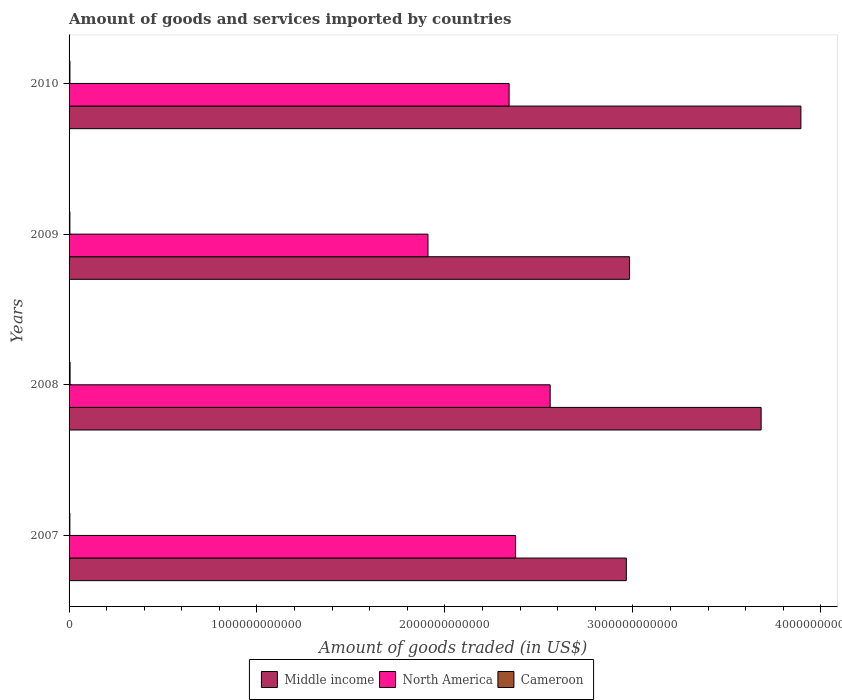Are the number of bars per tick equal to the number of legend labels?
Your answer should be very brief. Yes. How many bars are there on the 2nd tick from the top?
Provide a short and direct response. 3. What is the label of the 2nd group of bars from the top?
Your answer should be very brief. 2009. In how many cases, is the number of bars for a given year not equal to the number of legend labels?
Keep it short and to the point. 0. What is the total amount of goods and services imported in North America in 2010?
Offer a very short reply. 2.34e+12. Across all years, what is the maximum total amount of goods and services imported in Cameroon?
Offer a very short reply. 5.36e+09. Across all years, what is the minimum total amount of goods and services imported in North America?
Your response must be concise. 1.91e+12. In which year was the total amount of goods and services imported in Cameroon maximum?
Offer a very short reply. 2008. What is the total total amount of goods and services imported in North America in the graph?
Your answer should be very brief. 9.19e+12. What is the difference between the total amount of goods and services imported in Middle income in 2008 and that in 2010?
Give a very brief answer. -2.12e+11. What is the difference between the total amount of goods and services imported in Middle income in 2008 and the total amount of goods and services imported in North America in 2007?
Your answer should be compact. 1.31e+12. What is the average total amount of goods and services imported in Cameroon per year?
Keep it short and to the point. 4.62e+09. In the year 2008, what is the difference between the total amount of goods and services imported in Middle income and total amount of goods and services imported in North America?
Ensure brevity in your answer.  1.12e+12. In how many years, is the total amount of goods and services imported in North America greater than 1800000000000 US$?
Your answer should be very brief. 4. What is the ratio of the total amount of goods and services imported in Middle income in 2007 to that in 2009?
Give a very brief answer. 0.99. Is the total amount of goods and services imported in Middle income in 2008 less than that in 2009?
Your response must be concise. No. What is the difference between the highest and the second highest total amount of goods and services imported in Cameroon?
Keep it short and to the point. 7.32e+08. What is the difference between the highest and the lowest total amount of goods and services imported in Middle income?
Your answer should be compact. 9.29e+11. What does the 1st bar from the bottom in 2008 represents?
Offer a terse response. Middle income. Is it the case that in every year, the sum of the total amount of goods and services imported in Middle income and total amount of goods and services imported in North America is greater than the total amount of goods and services imported in Cameroon?
Your answer should be compact. Yes. What is the difference between two consecutive major ticks on the X-axis?
Your answer should be very brief. 1.00e+12. Are the values on the major ticks of X-axis written in scientific E-notation?
Your response must be concise. No. Does the graph contain any zero values?
Make the answer very short. No. Does the graph contain grids?
Offer a terse response. No. How many legend labels are there?
Your response must be concise. 3. What is the title of the graph?
Provide a short and direct response. Amount of goods and services imported by countries. What is the label or title of the X-axis?
Make the answer very short. Amount of goods traded (in US$). What is the label or title of the Y-axis?
Your answer should be very brief. Years. What is the Amount of goods traded (in US$) in Middle income in 2007?
Ensure brevity in your answer.  2.97e+12. What is the Amount of goods traded (in US$) in North America in 2007?
Provide a short and direct response. 2.38e+12. What is the Amount of goods traded (in US$) of Cameroon in 2007?
Offer a very short reply. 4.22e+09. What is the Amount of goods traded (in US$) in Middle income in 2008?
Keep it short and to the point. 3.68e+12. What is the Amount of goods traded (in US$) of North America in 2008?
Your answer should be very brief. 2.56e+12. What is the Amount of goods traded (in US$) of Cameroon in 2008?
Provide a succinct answer. 5.36e+09. What is the Amount of goods traded (in US$) in Middle income in 2009?
Make the answer very short. 2.98e+12. What is the Amount of goods traded (in US$) of North America in 2009?
Keep it short and to the point. 1.91e+12. What is the Amount of goods traded (in US$) of Cameroon in 2009?
Ensure brevity in your answer.  4.27e+09. What is the Amount of goods traded (in US$) in Middle income in 2010?
Offer a terse response. 3.89e+12. What is the Amount of goods traded (in US$) of North America in 2010?
Offer a very short reply. 2.34e+12. What is the Amount of goods traded (in US$) of Cameroon in 2010?
Your answer should be compact. 4.63e+09. Across all years, what is the maximum Amount of goods traded (in US$) of Middle income?
Provide a succinct answer. 3.89e+12. Across all years, what is the maximum Amount of goods traded (in US$) of North America?
Provide a succinct answer. 2.56e+12. Across all years, what is the maximum Amount of goods traded (in US$) in Cameroon?
Your response must be concise. 5.36e+09. Across all years, what is the minimum Amount of goods traded (in US$) of Middle income?
Your answer should be very brief. 2.97e+12. Across all years, what is the minimum Amount of goods traded (in US$) in North America?
Ensure brevity in your answer.  1.91e+12. Across all years, what is the minimum Amount of goods traded (in US$) in Cameroon?
Ensure brevity in your answer.  4.22e+09. What is the total Amount of goods traded (in US$) of Middle income in the graph?
Provide a short and direct response. 1.35e+13. What is the total Amount of goods traded (in US$) in North America in the graph?
Your response must be concise. 9.19e+12. What is the total Amount of goods traded (in US$) of Cameroon in the graph?
Provide a short and direct response. 1.85e+1. What is the difference between the Amount of goods traded (in US$) in Middle income in 2007 and that in 2008?
Your answer should be compact. -7.17e+11. What is the difference between the Amount of goods traded (in US$) in North America in 2007 and that in 2008?
Your response must be concise. -1.84e+11. What is the difference between the Amount of goods traded (in US$) of Cameroon in 2007 and that in 2008?
Your answer should be very brief. -1.14e+09. What is the difference between the Amount of goods traded (in US$) of Middle income in 2007 and that in 2009?
Your response must be concise. -1.71e+1. What is the difference between the Amount of goods traded (in US$) in North America in 2007 and that in 2009?
Ensure brevity in your answer.  4.66e+11. What is the difference between the Amount of goods traded (in US$) in Cameroon in 2007 and that in 2009?
Provide a succinct answer. -5.08e+07. What is the difference between the Amount of goods traded (in US$) of Middle income in 2007 and that in 2010?
Your response must be concise. -9.29e+11. What is the difference between the Amount of goods traded (in US$) of North America in 2007 and that in 2010?
Give a very brief answer. 3.43e+1. What is the difference between the Amount of goods traded (in US$) of Cameroon in 2007 and that in 2010?
Make the answer very short. -4.05e+08. What is the difference between the Amount of goods traded (in US$) of Middle income in 2008 and that in 2009?
Offer a very short reply. 7.00e+11. What is the difference between the Amount of goods traded (in US$) of North America in 2008 and that in 2009?
Give a very brief answer. 6.50e+11. What is the difference between the Amount of goods traded (in US$) in Cameroon in 2008 and that in 2009?
Keep it short and to the point. 1.09e+09. What is the difference between the Amount of goods traded (in US$) of Middle income in 2008 and that in 2010?
Your response must be concise. -2.12e+11. What is the difference between the Amount of goods traded (in US$) of North America in 2008 and that in 2010?
Ensure brevity in your answer.  2.18e+11. What is the difference between the Amount of goods traded (in US$) of Cameroon in 2008 and that in 2010?
Offer a very short reply. 7.32e+08. What is the difference between the Amount of goods traded (in US$) of Middle income in 2009 and that in 2010?
Provide a succinct answer. -9.12e+11. What is the difference between the Amount of goods traded (in US$) of North America in 2009 and that in 2010?
Keep it short and to the point. -4.32e+11. What is the difference between the Amount of goods traded (in US$) in Cameroon in 2009 and that in 2010?
Provide a short and direct response. -3.54e+08. What is the difference between the Amount of goods traded (in US$) in Middle income in 2007 and the Amount of goods traded (in US$) in North America in 2008?
Your response must be concise. 4.05e+11. What is the difference between the Amount of goods traded (in US$) in Middle income in 2007 and the Amount of goods traded (in US$) in Cameroon in 2008?
Ensure brevity in your answer.  2.96e+12. What is the difference between the Amount of goods traded (in US$) in North America in 2007 and the Amount of goods traded (in US$) in Cameroon in 2008?
Your answer should be compact. 2.37e+12. What is the difference between the Amount of goods traded (in US$) of Middle income in 2007 and the Amount of goods traded (in US$) of North America in 2009?
Make the answer very short. 1.06e+12. What is the difference between the Amount of goods traded (in US$) of Middle income in 2007 and the Amount of goods traded (in US$) of Cameroon in 2009?
Offer a very short reply. 2.96e+12. What is the difference between the Amount of goods traded (in US$) in North America in 2007 and the Amount of goods traded (in US$) in Cameroon in 2009?
Offer a terse response. 2.37e+12. What is the difference between the Amount of goods traded (in US$) in Middle income in 2007 and the Amount of goods traded (in US$) in North America in 2010?
Provide a succinct answer. 6.24e+11. What is the difference between the Amount of goods traded (in US$) of Middle income in 2007 and the Amount of goods traded (in US$) of Cameroon in 2010?
Offer a very short reply. 2.96e+12. What is the difference between the Amount of goods traded (in US$) in North America in 2007 and the Amount of goods traded (in US$) in Cameroon in 2010?
Offer a terse response. 2.37e+12. What is the difference between the Amount of goods traded (in US$) in Middle income in 2008 and the Amount of goods traded (in US$) in North America in 2009?
Provide a succinct answer. 1.77e+12. What is the difference between the Amount of goods traded (in US$) of Middle income in 2008 and the Amount of goods traded (in US$) of Cameroon in 2009?
Provide a succinct answer. 3.68e+12. What is the difference between the Amount of goods traded (in US$) of North America in 2008 and the Amount of goods traded (in US$) of Cameroon in 2009?
Your answer should be compact. 2.56e+12. What is the difference between the Amount of goods traded (in US$) in Middle income in 2008 and the Amount of goods traded (in US$) in North America in 2010?
Your answer should be very brief. 1.34e+12. What is the difference between the Amount of goods traded (in US$) of Middle income in 2008 and the Amount of goods traded (in US$) of Cameroon in 2010?
Keep it short and to the point. 3.68e+12. What is the difference between the Amount of goods traded (in US$) in North America in 2008 and the Amount of goods traded (in US$) in Cameroon in 2010?
Your response must be concise. 2.56e+12. What is the difference between the Amount of goods traded (in US$) in Middle income in 2009 and the Amount of goods traded (in US$) in North America in 2010?
Give a very brief answer. 6.41e+11. What is the difference between the Amount of goods traded (in US$) of Middle income in 2009 and the Amount of goods traded (in US$) of Cameroon in 2010?
Your answer should be compact. 2.98e+12. What is the difference between the Amount of goods traded (in US$) in North America in 2009 and the Amount of goods traded (in US$) in Cameroon in 2010?
Your answer should be compact. 1.91e+12. What is the average Amount of goods traded (in US$) in Middle income per year?
Make the answer very short. 3.38e+12. What is the average Amount of goods traded (in US$) of North America per year?
Offer a very short reply. 2.30e+12. What is the average Amount of goods traded (in US$) in Cameroon per year?
Offer a terse response. 4.62e+09. In the year 2007, what is the difference between the Amount of goods traded (in US$) in Middle income and Amount of goods traded (in US$) in North America?
Offer a terse response. 5.89e+11. In the year 2007, what is the difference between the Amount of goods traded (in US$) in Middle income and Amount of goods traded (in US$) in Cameroon?
Provide a short and direct response. 2.96e+12. In the year 2007, what is the difference between the Amount of goods traded (in US$) in North America and Amount of goods traded (in US$) in Cameroon?
Give a very brief answer. 2.37e+12. In the year 2008, what is the difference between the Amount of goods traded (in US$) in Middle income and Amount of goods traded (in US$) in North America?
Provide a short and direct response. 1.12e+12. In the year 2008, what is the difference between the Amount of goods traded (in US$) of Middle income and Amount of goods traded (in US$) of Cameroon?
Ensure brevity in your answer.  3.68e+12. In the year 2008, what is the difference between the Amount of goods traded (in US$) of North America and Amount of goods traded (in US$) of Cameroon?
Provide a succinct answer. 2.55e+12. In the year 2009, what is the difference between the Amount of goods traded (in US$) in Middle income and Amount of goods traded (in US$) in North America?
Offer a terse response. 1.07e+12. In the year 2009, what is the difference between the Amount of goods traded (in US$) of Middle income and Amount of goods traded (in US$) of Cameroon?
Give a very brief answer. 2.98e+12. In the year 2009, what is the difference between the Amount of goods traded (in US$) in North America and Amount of goods traded (in US$) in Cameroon?
Ensure brevity in your answer.  1.91e+12. In the year 2010, what is the difference between the Amount of goods traded (in US$) of Middle income and Amount of goods traded (in US$) of North America?
Your answer should be very brief. 1.55e+12. In the year 2010, what is the difference between the Amount of goods traded (in US$) of Middle income and Amount of goods traded (in US$) of Cameroon?
Offer a terse response. 3.89e+12. In the year 2010, what is the difference between the Amount of goods traded (in US$) in North America and Amount of goods traded (in US$) in Cameroon?
Offer a very short reply. 2.34e+12. What is the ratio of the Amount of goods traded (in US$) of Middle income in 2007 to that in 2008?
Offer a terse response. 0.81. What is the ratio of the Amount of goods traded (in US$) of North America in 2007 to that in 2008?
Give a very brief answer. 0.93. What is the ratio of the Amount of goods traded (in US$) in Cameroon in 2007 to that in 2008?
Your answer should be very brief. 0.79. What is the ratio of the Amount of goods traded (in US$) of North America in 2007 to that in 2009?
Ensure brevity in your answer.  1.24. What is the ratio of the Amount of goods traded (in US$) of Cameroon in 2007 to that in 2009?
Offer a terse response. 0.99. What is the ratio of the Amount of goods traded (in US$) of Middle income in 2007 to that in 2010?
Keep it short and to the point. 0.76. What is the ratio of the Amount of goods traded (in US$) of North America in 2007 to that in 2010?
Make the answer very short. 1.01. What is the ratio of the Amount of goods traded (in US$) in Cameroon in 2007 to that in 2010?
Make the answer very short. 0.91. What is the ratio of the Amount of goods traded (in US$) in Middle income in 2008 to that in 2009?
Your answer should be very brief. 1.23. What is the ratio of the Amount of goods traded (in US$) in North America in 2008 to that in 2009?
Keep it short and to the point. 1.34. What is the ratio of the Amount of goods traded (in US$) in Cameroon in 2008 to that in 2009?
Make the answer very short. 1.25. What is the ratio of the Amount of goods traded (in US$) in Middle income in 2008 to that in 2010?
Give a very brief answer. 0.95. What is the ratio of the Amount of goods traded (in US$) in North America in 2008 to that in 2010?
Ensure brevity in your answer.  1.09. What is the ratio of the Amount of goods traded (in US$) in Cameroon in 2008 to that in 2010?
Make the answer very short. 1.16. What is the ratio of the Amount of goods traded (in US$) in Middle income in 2009 to that in 2010?
Your response must be concise. 0.77. What is the ratio of the Amount of goods traded (in US$) in North America in 2009 to that in 2010?
Ensure brevity in your answer.  0.82. What is the ratio of the Amount of goods traded (in US$) of Cameroon in 2009 to that in 2010?
Provide a short and direct response. 0.92. What is the difference between the highest and the second highest Amount of goods traded (in US$) of Middle income?
Offer a terse response. 2.12e+11. What is the difference between the highest and the second highest Amount of goods traded (in US$) in North America?
Ensure brevity in your answer.  1.84e+11. What is the difference between the highest and the second highest Amount of goods traded (in US$) of Cameroon?
Your answer should be very brief. 7.32e+08. What is the difference between the highest and the lowest Amount of goods traded (in US$) of Middle income?
Your answer should be very brief. 9.29e+11. What is the difference between the highest and the lowest Amount of goods traded (in US$) in North America?
Keep it short and to the point. 6.50e+11. What is the difference between the highest and the lowest Amount of goods traded (in US$) of Cameroon?
Your response must be concise. 1.14e+09. 